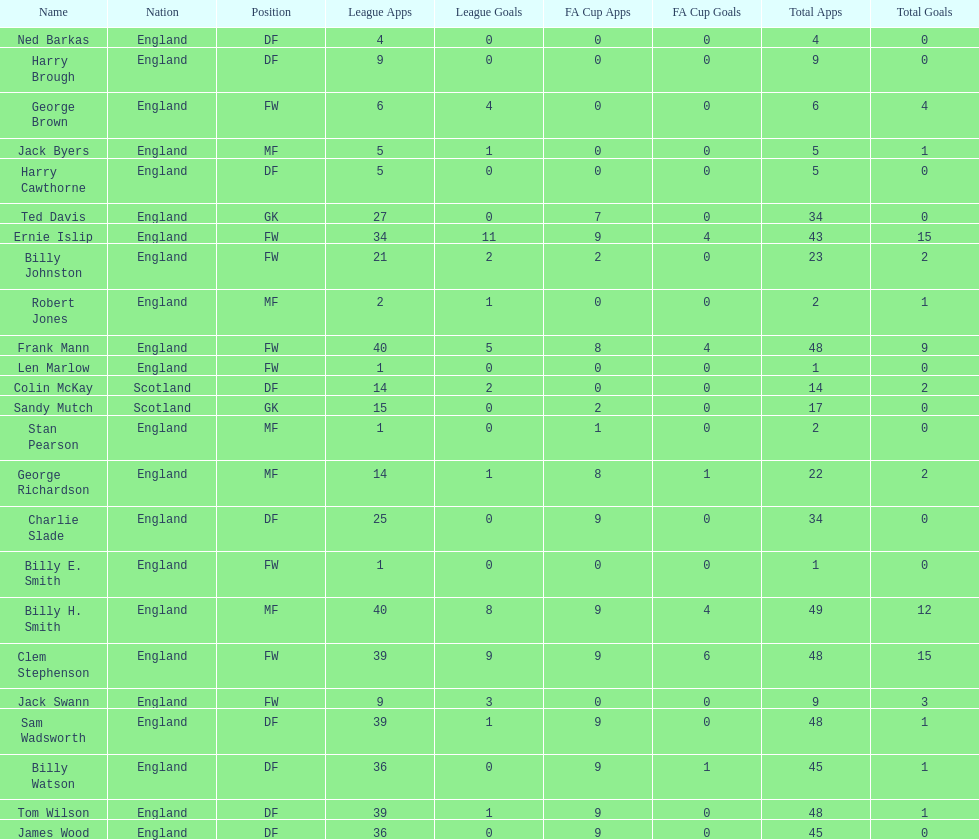The minimum amount of total occurrences 1. Parse the table in full. {'header': ['Name', 'Nation', 'Position', 'League Apps', 'League Goals', 'FA Cup Apps', 'FA Cup Goals', 'Total Apps', 'Total Goals'], 'rows': [['Ned Barkas', 'England', 'DF', '4', '0', '0', '0', '4', '0'], ['Harry Brough', 'England', 'DF', '9', '0', '0', '0', '9', '0'], ['George Brown', 'England', 'FW', '6', '4', '0', '0', '6', '4'], ['Jack Byers', 'England', 'MF', '5', '1', '0', '0', '5', '1'], ['Harry Cawthorne', 'England', 'DF', '5', '0', '0', '0', '5', '0'], ['Ted Davis', 'England', 'GK', '27', '0', '7', '0', '34', '0'], ['Ernie Islip', 'England', 'FW', '34', '11', '9', '4', '43', '15'], ['Billy Johnston', 'England', 'FW', '21', '2', '2', '0', '23', '2'], ['Robert Jones', 'England', 'MF', '2', '1', '0', '0', '2', '1'], ['Frank Mann', 'England', 'FW', '40', '5', '8', '4', '48', '9'], ['Len Marlow', 'England', 'FW', '1', '0', '0', '0', '1', '0'], ['Colin McKay', 'Scotland', 'DF', '14', '2', '0', '0', '14', '2'], ['Sandy Mutch', 'Scotland', 'GK', '15', '0', '2', '0', '17', '0'], ['Stan Pearson', 'England', 'MF', '1', '0', '1', '0', '2', '0'], ['George Richardson', 'England', 'MF', '14', '1', '8', '1', '22', '2'], ['Charlie Slade', 'England', 'DF', '25', '0', '9', '0', '34', '0'], ['Billy E. Smith', 'England', 'FW', '1', '0', '0', '0', '1', '0'], ['Billy H. Smith', 'England', 'MF', '40', '8', '9', '4', '49', '12'], ['Clem Stephenson', 'England', 'FW', '39', '9', '9', '6', '48', '15'], ['Jack Swann', 'England', 'FW', '9', '3', '0', '0', '9', '3'], ['Sam Wadsworth', 'England', 'DF', '39', '1', '9', '0', '48', '1'], ['Billy Watson', 'England', 'DF', '36', '0', '9', '1', '45', '1'], ['Tom Wilson', 'England', 'DF', '39', '1', '9', '0', '48', '1'], ['James Wood', 'England', 'DF', '36', '0', '9', '0', '45', '0']]} 